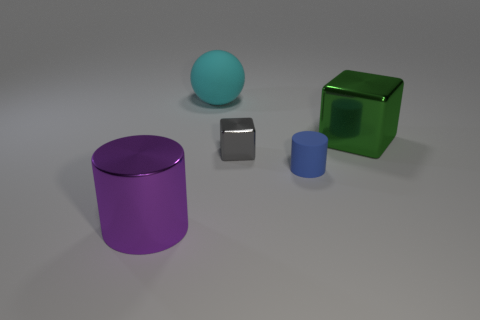How would you describe the setting of these objects? The objects are placed on a flat, even surface with a neutral tone, suggesting a controlled environment such as a studio setup. The lighting is soft and diffused, highlighting the objects without harsh shadows, perfect for showcasing their shapes and colors without distraction. 